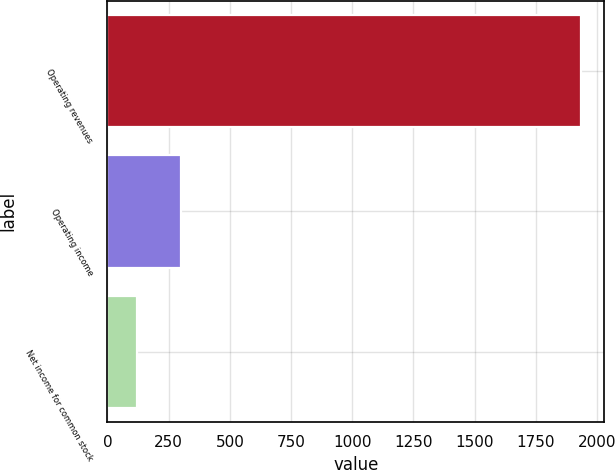<chart> <loc_0><loc_0><loc_500><loc_500><bar_chart><fcel>Operating revenues<fcel>Operating income<fcel>Net income for common stock<nl><fcel>1933<fcel>302.2<fcel>121<nl></chart> 